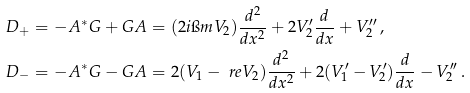Convert formula to latex. <formula><loc_0><loc_0><loc_500><loc_500>D _ { + } & = - A ^ { * } G + G A = ( 2 i \i m V _ { 2 } ) \frac { d ^ { 2 } } { d x ^ { 2 } } + 2 V _ { 2 } ^ { \prime } \frac { d } { d x } + V _ { 2 } ^ { \prime \prime } \, , \\ D _ { - } & = - A ^ { * } G - G A = 2 ( V _ { 1 } - \ r e V _ { 2 } ) \frac { d ^ { 2 } } { d x ^ { 2 } } + 2 ( V _ { 1 } ^ { \prime } - V _ { 2 } ^ { \prime } ) \frac { d } { d x } - V _ { 2 } ^ { \prime \prime } \, .</formula> 